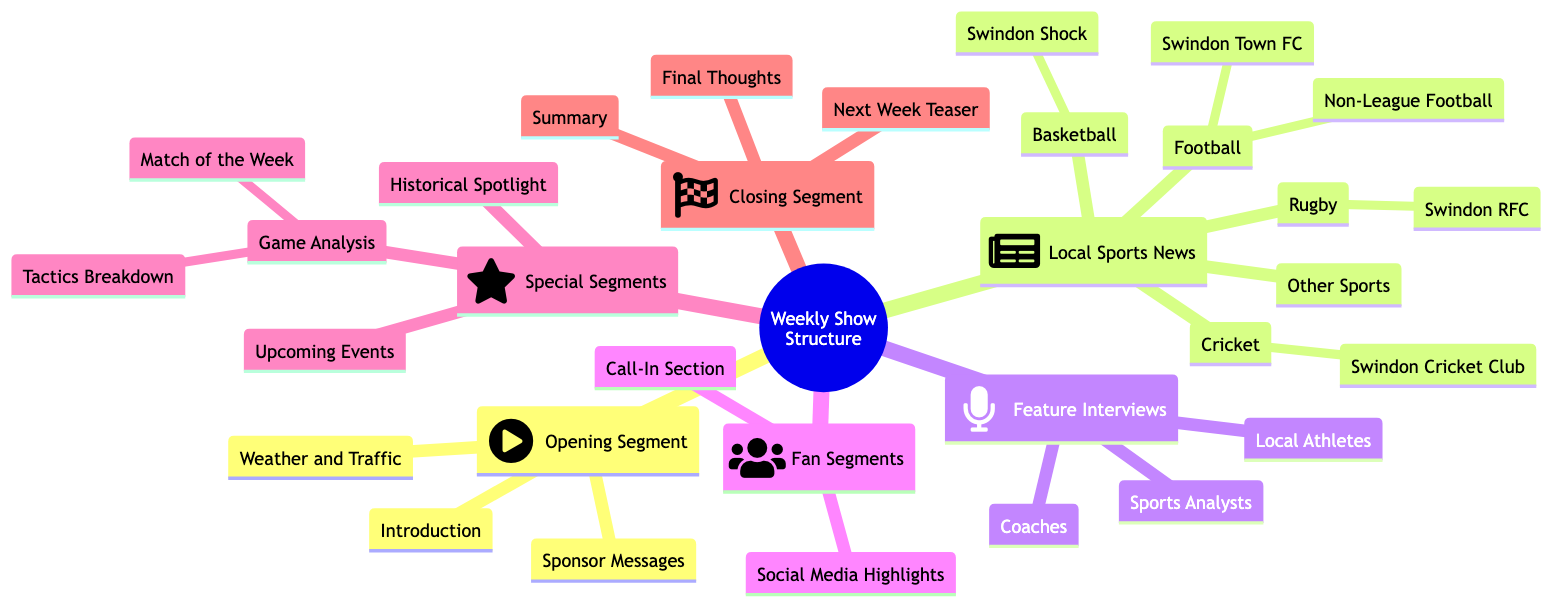What is the first segment in the show structure? The first segment listed in the diagram under "Weekly Show Structure and Content Segments" is "Opening Segment." It is the first node after the root node.
Answer: Opening Segment How many types of local sports news are featured? The "Local Sports News" section includes five types: Football, Rugby, Basketball, Cricket, and Other Sports. These are distinct categories listed under this node.
Answer: 5 What is included in the "Game Analysis" special segment? The "Game Analysis" special segment includes two aspects: "Match of the Week" and "Tactics Breakdown." These are the two child nodes under the "Game Analysis" node.
Answer: Match of the Week, Tactics Breakdown Which local football club is specifically mentioned in the diagram? The diagram explicitly mentions "Swindon Town FC" under the "Football" category in the "Local Sports News" section.
Answer: Swindon Town FC What type of content is included in the "Feature Interviews" segment? The "Feature Interviews" segment contains in-depth interactions with three types of individuals: "Local Athletes," "Coaches," and "Sports Analysts." These types are listed as the subcategories under this segment.
Answer: Local Athletes, Coaches, Sports Analysts Which segment concludes the show structure? The last segment listed in the diagram under "Weekly Show Structure and Content Segments" is "Closing Segment," which is positioned at the end of the main categories.
Answer: Closing Segment What does the "Next Week Teaser" address? The "Next Week Teaser" is part of the "Closing Segment," focusing on highlighting what's coming up in the next show. This specific purpose is listed clearly in the diagram under the respective node.
Answer: Highlighting what's coming up in the next show How many fan segments are there? There are two fan segments listed in the diagram: "Call-In Section" and "Social Media Highlights," indicating direct interaction opportunities for listeners.
Answer: 2 What type of content does the "Historical Spotlight" cover? The "Historical Spotlight" is a special segment that focuses on looking back at significant sports events in Swindon's history, as indicated in the diagram under the "Special Segments."
Answer: Significant sports events in Swindon's history 